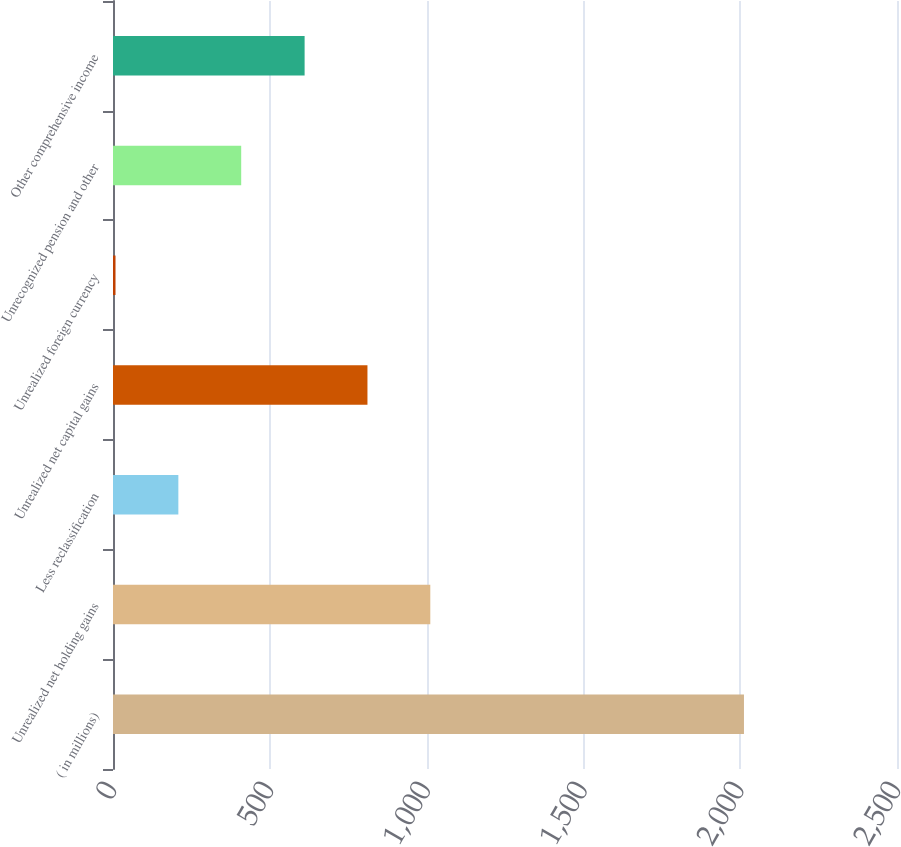<chart> <loc_0><loc_0><loc_500><loc_500><bar_chart><fcel>( in millions)<fcel>Unrealized net holding gains<fcel>Less reclassification<fcel>Unrealized net capital gains<fcel>Unrealized foreign currency<fcel>Unrecognized pension and other<fcel>Other comprehensive income<nl><fcel>2012<fcel>1011.8<fcel>208.4<fcel>811.4<fcel>8<fcel>408.8<fcel>611<nl></chart> 